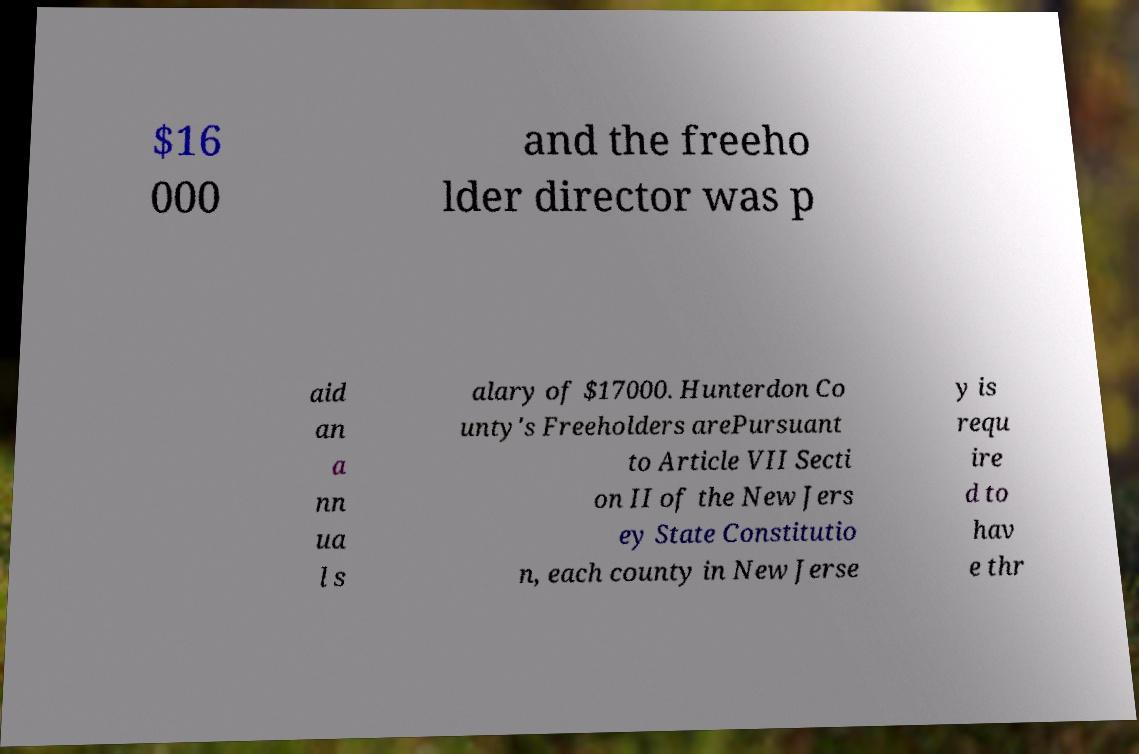Can you accurately transcribe the text from the provided image for me? $16 000 and the freeho lder director was p aid an a nn ua l s alary of $17000. Hunterdon Co unty's Freeholders arePursuant to Article VII Secti on II of the New Jers ey State Constitutio n, each county in New Jerse y is requ ire d to hav e thr 